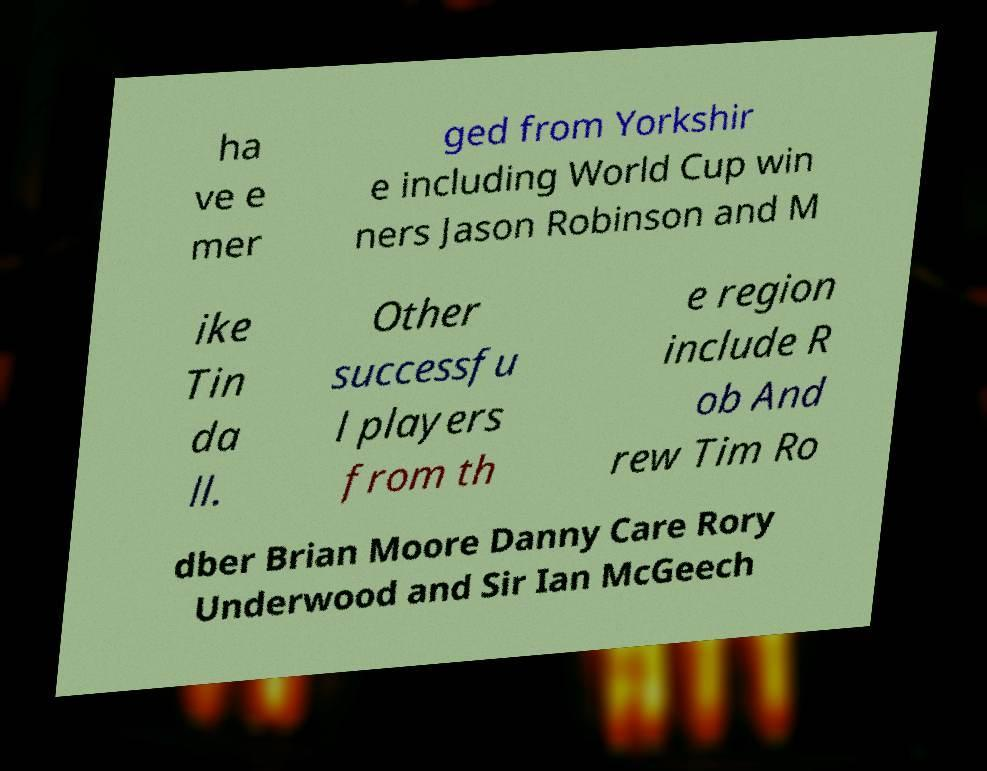There's text embedded in this image that I need extracted. Can you transcribe it verbatim? ha ve e mer ged from Yorkshir e including World Cup win ners Jason Robinson and M ike Tin da ll. Other successfu l players from th e region include R ob And rew Tim Ro dber Brian Moore Danny Care Rory Underwood and Sir Ian McGeech 